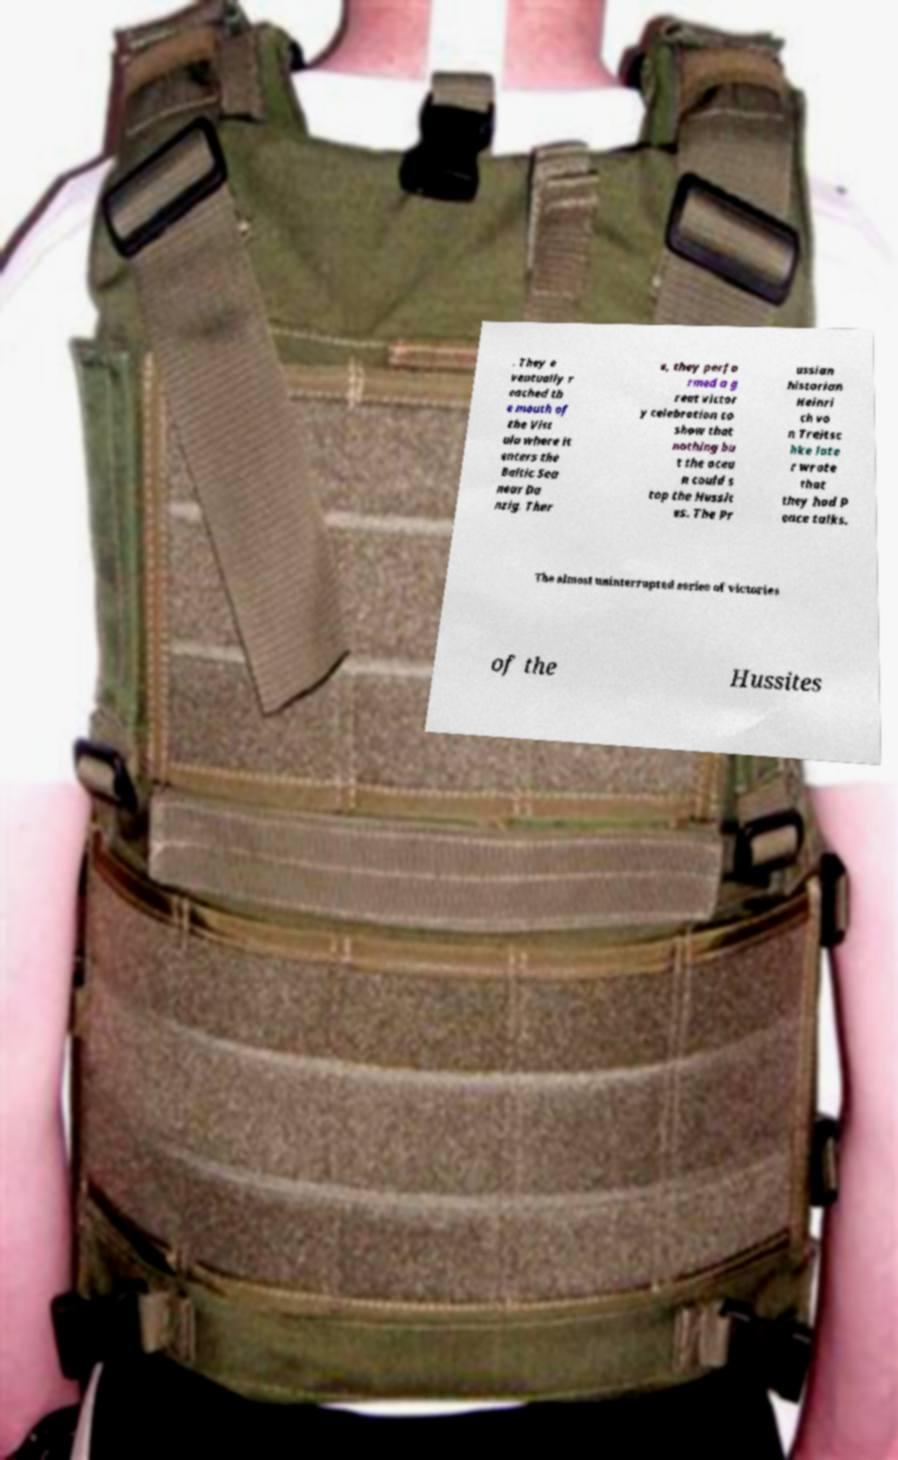What messages or text are displayed in this image? I need them in a readable, typed format. . They e ventually r eached th e mouth of the Vist ula where it enters the Baltic Sea near Da nzig. Ther e, they perfo rmed a g reat victor y celebration to show that nothing bu t the ocea n could s top the Hussit es. The Pr ussian historian Heinri ch vo n Treitsc hke late r wrote that they had P eace talks. The almost uninterrupted series of victories of the Hussites 